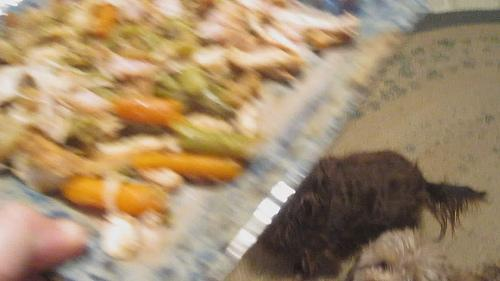Explain the situation shown in the image as if creating a narrative for a visual entailment project. The image captures a delightful moment where a person is serving a silver tray filled with sumptuous food items such as chicken, carrot, green bean, and broccoli. In the background, a lovable dark brown dog watches the scene, creating a warm and inviting atmosphere. Select a task and provide a detailed description of the content in the image for that task. For a product advertisement task, an eye-catching image of a silver serving tray filled with various delicious food items, such as cut-up chicken, yellow chunks, green beans, and broccoli, is presented. A person's hand is also visible, holding the tray, to emphasize the convenience of its use. A cute dark brown dog is in the background, which adds an emotional appeal to the ad. Given the objects in the image, formulate a tagline suitable for a product advertisement. "Serve your culinary masterpiece in style with our sleek silver tray—so appetizing that even your furry friend can't resist!" Provide a brief introduction to the image, suitable for a product advertisement campaign. Introducing the ultimate silver serving tray - perfect for presenting a delicious assortment of foods! Feast your eyes on mouth-watering chicken, fresh vegetables, and more, all while enjoying the company of your furry friend. Describe a scene in the image that could serve as a basis for a visual entailment task. A person is holding a silver tray, filled with various appetizing food items such as chicken, green beans, and broccoli, demonstrating a presentation that invites people to enjoy the meal together while a curious dark brown dog gazes at the tray from the background. 